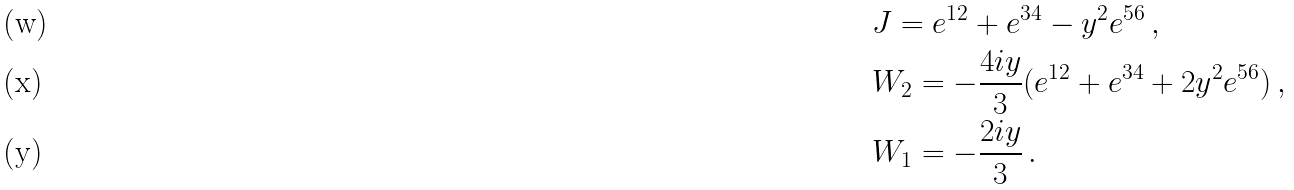<formula> <loc_0><loc_0><loc_500><loc_500>& J = e ^ { 1 2 } + e ^ { 3 4 } - y ^ { 2 } e ^ { 5 6 } \, , \\ & W _ { 2 } = - \frac { 4 i y } { 3 } ( e ^ { 1 2 } + e ^ { 3 4 } + 2 y ^ { 2 } e ^ { 5 6 } ) \, , \\ & W _ { 1 } = - \frac { 2 i y } { 3 } \, .</formula> 